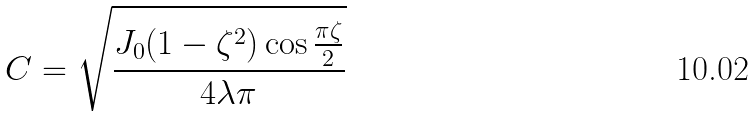Convert formula to latex. <formula><loc_0><loc_0><loc_500><loc_500>C = \sqrt { \frac { J _ { 0 } ( 1 - \zeta ^ { 2 } ) \cos \frac { \pi \zeta } { 2 } } { 4 \lambda \pi } }</formula> 